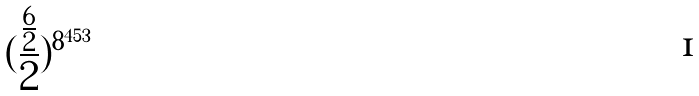Convert formula to latex. <formula><loc_0><loc_0><loc_500><loc_500>( \frac { \frac { 6 } { 2 } } { 2 } ) ^ { 8 ^ { 4 5 3 } }</formula> 